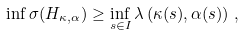<formula> <loc_0><loc_0><loc_500><loc_500>\inf \sigma ( H _ { \kappa , \alpha } ) \geq \inf _ { s \in I } \lambda \left ( \kappa ( s ) , \alpha ( s ) \right ) \, ,</formula> 